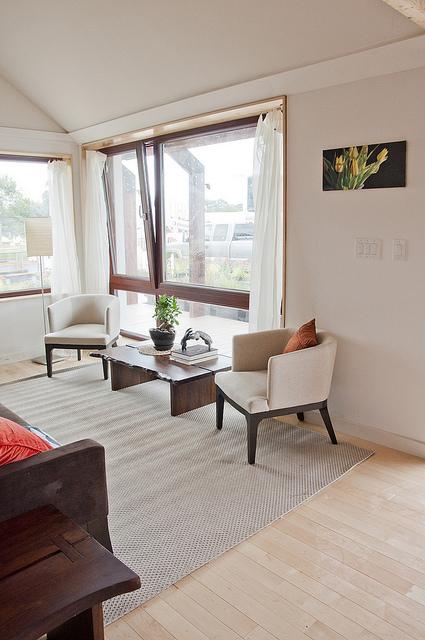How many window panes are there?
Keep it brief. 3. Do the two couches match?
Answer briefly. Yes. How many tables are in the room?
Be succinct. 1. Where is the table and chairs?
Keep it brief. By window. What kind of flowers are in the picture?
Give a very brief answer. Tulips. What is on the windows?
Quick response, please. Curtains. What color is the seat cushion?
Concise answer only. White. 